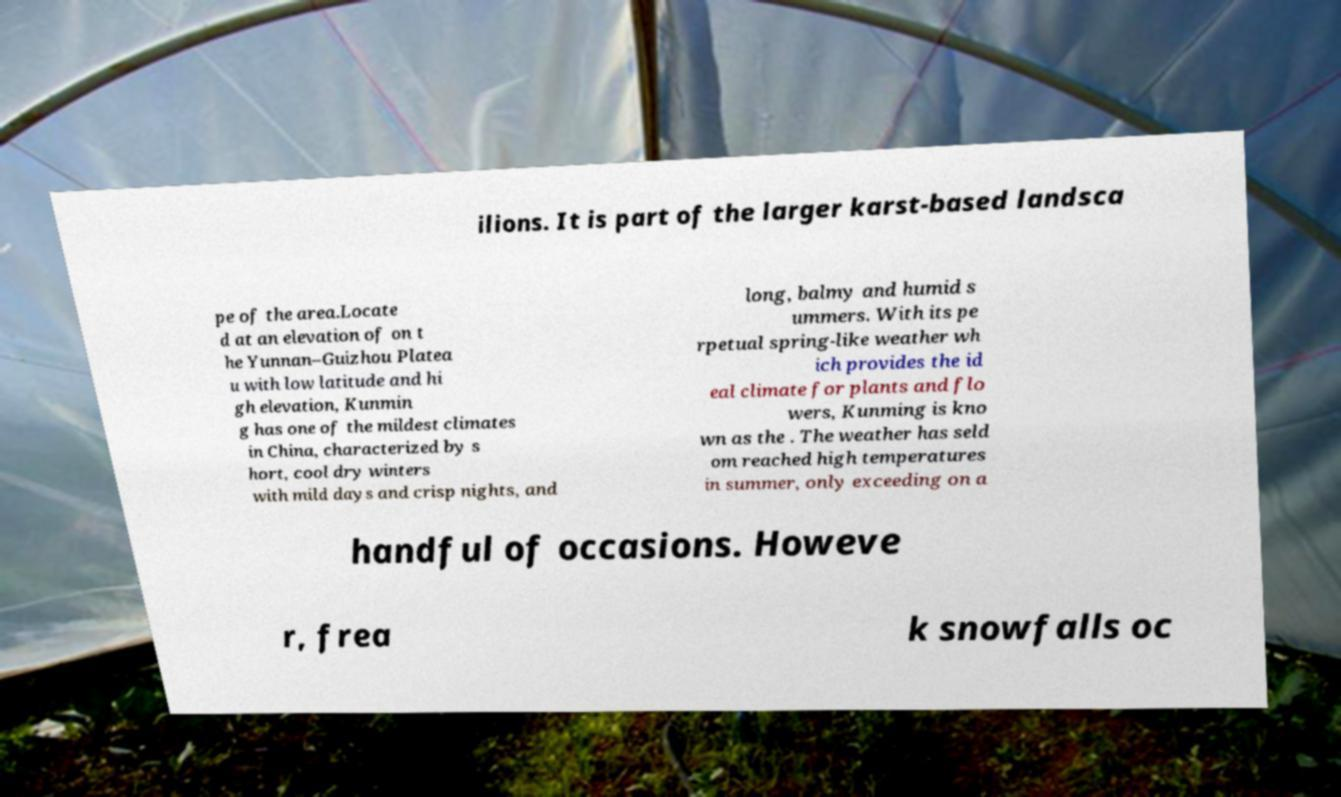Please identify and transcribe the text found in this image. ilions. It is part of the larger karst-based landsca pe of the area.Locate d at an elevation of on t he Yunnan–Guizhou Platea u with low latitude and hi gh elevation, Kunmin g has one of the mildest climates in China, characterized by s hort, cool dry winters with mild days and crisp nights, and long, balmy and humid s ummers. With its pe rpetual spring-like weather wh ich provides the id eal climate for plants and flo wers, Kunming is kno wn as the . The weather has seld om reached high temperatures in summer, only exceeding on a handful of occasions. Howeve r, frea k snowfalls oc 